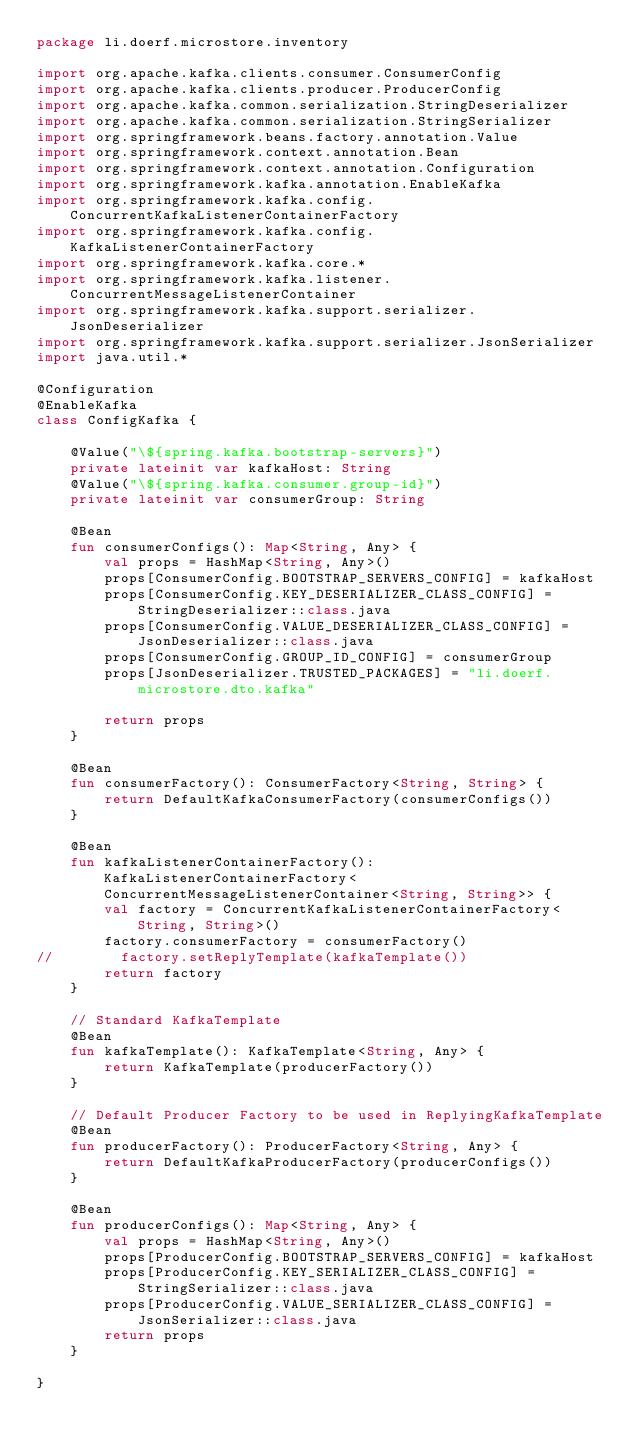Convert code to text. <code><loc_0><loc_0><loc_500><loc_500><_Kotlin_>package li.doerf.microstore.inventory

import org.apache.kafka.clients.consumer.ConsumerConfig
import org.apache.kafka.clients.producer.ProducerConfig
import org.apache.kafka.common.serialization.StringDeserializer
import org.apache.kafka.common.serialization.StringSerializer
import org.springframework.beans.factory.annotation.Value
import org.springframework.context.annotation.Bean
import org.springframework.context.annotation.Configuration
import org.springframework.kafka.annotation.EnableKafka
import org.springframework.kafka.config.ConcurrentKafkaListenerContainerFactory
import org.springframework.kafka.config.KafkaListenerContainerFactory
import org.springframework.kafka.core.*
import org.springframework.kafka.listener.ConcurrentMessageListenerContainer
import org.springframework.kafka.support.serializer.JsonDeserializer
import org.springframework.kafka.support.serializer.JsonSerializer
import java.util.*

@Configuration
@EnableKafka
class ConfigKafka {

    @Value("\${spring.kafka.bootstrap-servers}")
    private lateinit var kafkaHost: String
    @Value("\${spring.kafka.consumer.group-id}")
    private lateinit var consumerGroup: String

    @Bean
    fun consumerConfigs(): Map<String, Any> {
        val props = HashMap<String, Any>()
        props[ConsumerConfig.BOOTSTRAP_SERVERS_CONFIG] = kafkaHost
        props[ConsumerConfig.KEY_DESERIALIZER_CLASS_CONFIG] = StringDeserializer::class.java
        props[ConsumerConfig.VALUE_DESERIALIZER_CLASS_CONFIG] = JsonDeserializer::class.java
        props[ConsumerConfig.GROUP_ID_CONFIG] = consumerGroup
        props[JsonDeserializer.TRUSTED_PACKAGES] = "li.doerf.microstore.dto.kafka"

        return props
    }

    @Bean
    fun consumerFactory(): ConsumerFactory<String, String> {
        return DefaultKafkaConsumerFactory(consumerConfigs())
    }

    @Bean
    fun kafkaListenerContainerFactory(): KafkaListenerContainerFactory<ConcurrentMessageListenerContainer<String, String>> {
        val factory = ConcurrentKafkaListenerContainerFactory<String, String>()
        factory.consumerFactory = consumerFactory()
//        factory.setReplyTemplate(kafkaTemplate())
        return factory
    }

    // Standard KafkaTemplate
    @Bean
    fun kafkaTemplate(): KafkaTemplate<String, Any> {
        return KafkaTemplate(producerFactory())
    }

    // Default Producer Factory to be used in ReplyingKafkaTemplate
    @Bean
    fun producerFactory(): ProducerFactory<String, Any> {
        return DefaultKafkaProducerFactory(producerConfigs())
    }

    @Bean
    fun producerConfigs(): Map<String, Any> {
        val props = HashMap<String, Any>()
        props[ProducerConfig.BOOTSTRAP_SERVERS_CONFIG] = kafkaHost
        props[ProducerConfig.KEY_SERIALIZER_CLASS_CONFIG] = StringSerializer::class.java
        props[ProducerConfig.VALUE_SERIALIZER_CLASS_CONFIG] = JsonSerializer::class.java
        return props
    }

}</code> 